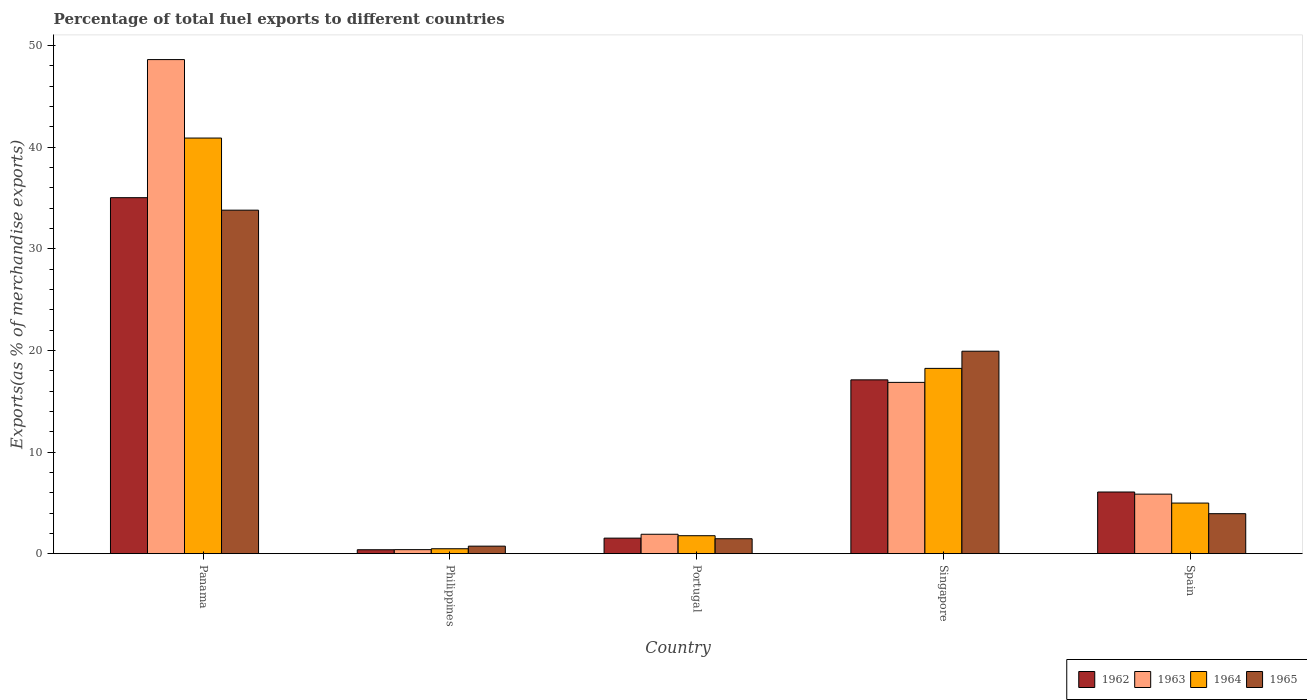How many different coloured bars are there?
Offer a very short reply. 4. How many groups of bars are there?
Provide a short and direct response. 5. What is the percentage of exports to different countries in 1963 in Singapore?
Offer a very short reply. 16.85. Across all countries, what is the maximum percentage of exports to different countries in 1965?
Provide a short and direct response. 33.8. Across all countries, what is the minimum percentage of exports to different countries in 1964?
Offer a terse response. 0.48. In which country was the percentage of exports to different countries in 1963 maximum?
Give a very brief answer. Panama. What is the total percentage of exports to different countries in 1964 in the graph?
Provide a short and direct response. 66.36. What is the difference between the percentage of exports to different countries in 1962 in Singapore and that in Spain?
Keep it short and to the point. 11.04. What is the difference between the percentage of exports to different countries in 1962 in Singapore and the percentage of exports to different countries in 1963 in Spain?
Provide a succinct answer. 11.25. What is the average percentage of exports to different countries in 1963 per country?
Keep it short and to the point. 14.73. What is the difference between the percentage of exports to different countries of/in 1964 and percentage of exports to different countries of/in 1963 in Singapore?
Provide a succinct answer. 1.38. In how many countries, is the percentage of exports to different countries in 1964 greater than 16 %?
Offer a terse response. 2. What is the ratio of the percentage of exports to different countries in 1965 in Panama to that in Singapore?
Ensure brevity in your answer.  1.7. What is the difference between the highest and the second highest percentage of exports to different countries in 1964?
Your response must be concise. 22.67. What is the difference between the highest and the lowest percentage of exports to different countries in 1964?
Make the answer very short. 40.41. In how many countries, is the percentage of exports to different countries in 1965 greater than the average percentage of exports to different countries in 1965 taken over all countries?
Your answer should be compact. 2. Is the sum of the percentage of exports to different countries in 1962 in Philippines and Portugal greater than the maximum percentage of exports to different countries in 1964 across all countries?
Your answer should be very brief. No. What does the 1st bar from the right in Philippines represents?
Ensure brevity in your answer.  1965. How many bars are there?
Give a very brief answer. 20. Are all the bars in the graph horizontal?
Give a very brief answer. No. How many countries are there in the graph?
Keep it short and to the point. 5. What is the difference between two consecutive major ticks on the Y-axis?
Provide a succinct answer. 10. Are the values on the major ticks of Y-axis written in scientific E-notation?
Provide a short and direct response. No. Where does the legend appear in the graph?
Your answer should be compact. Bottom right. How are the legend labels stacked?
Your answer should be compact. Horizontal. What is the title of the graph?
Ensure brevity in your answer.  Percentage of total fuel exports to different countries. What is the label or title of the X-axis?
Give a very brief answer. Country. What is the label or title of the Y-axis?
Ensure brevity in your answer.  Exports(as % of merchandise exports). What is the Exports(as % of merchandise exports) of 1962 in Panama?
Keep it short and to the point. 35.03. What is the Exports(as % of merchandise exports) of 1963 in Panama?
Ensure brevity in your answer.  48.62. What is the Exports(as % of merchandise exports) of 1964 in Panama?
Give a very brief answer. 40.9. What is the Exports(as % of merchandise exports) in 1965 in Panama?
Your answer should be very brief. 33.8. What is the Exports(as % of merchandise exports) of 1962 in Philippines?
Offer a terse response. 0.38. What is the Exports(as % of merchandise exports) in 1963 in Philippines?
Keep it short and to the point. 0.4. What is the Exports(as % of merchandise exports) of 1964 in Philippines?
Your answer should be compact. 0.48. What is the Exports(as % of merchandise exports) of 1965 in Philippines?
Provide a short and direct response. 0.74. What is the Exports(as % of merchandise exports) of 1962 in Portugal?
Your answer should be compact. 1.53. What is the Exports(as % of merchandise exports) in 1963 in Portugal?
Your answer should be very brief. 1.91. What is the Exports(as % of merchandise exports) in 1964 in Portugal?
Give a very brief answer. 1.77. What is the Exports(as % of merchandise exports) in 1965 in Portugal?
Offer a very short reply. 1.47. What is the Exports(as % of merchandise exports) of 1962 in Singapore?
Give a very brief answer. 17.1. What is the Exports(as % of merchandise exports) in 1963 in Singapore?
Make the answer very short. 16.85. What is the Exports(as % of merchandise exports) in 1964 in Singapore?
Give a very brief answer. 18.23. What is the Exports(as % of merchandise exports) of 1965 in Singapore?
Your answer should be compact. 19.92. What is the Exports(as % of merchandise exports) of 1962 in Spain?
Make the answer very short. 6.07. What is the Exports(as % of merchandise exports) in 1963 in Spain?
Provide a short and direct response. 5.86. What is the Exports(as % of merchandise exports) in 1964 in Spain?
Give a very brief answer. 4.98. What is the Exports(as % of merchandise exports) in 1965 in Spain?
Offer a very short reply. 3.93. Across all countries, what is the maximum Exports(as % of merchandise exports) of 1962?
Your answer should be very brief. 35.03. Across all countries, what is the maximum Exports(as % of merchandise exports) in 1963?
Give a very brief answer. 48.62. Across all countries, what is the maximum Exports(as % of merchandise exports) of 1964?
Your answer should be compact. 40.9. Across all countries, what is the maximum Exports(as % of merchandise exports) of 1965?
Offer a terse response. 33.8. Across all countries, what is the minimum Exports(as % of merchandise exports) of 1962?
Your response must be concise. 0.38. Across all countries, what is the minimum Exports(as % of merchandise exports) of 1963?
Your answer should be compact. 0.4. Across all countries, what is the minimum Exports(as % of merchandise exports) in 1964?
Ensure brevity in your answer.  0.48. Across all countries, what is the minimum Exports(as % of merchandise exports) of 1965?
Offer a very short reply. 0.74. What is the total Exports(as % of merchandise exports) of 1962 in the graph?
Ensure brevity in your answer.  60.11. What is the total Exports(as % of merchandise exports) of 1963 in the graph?
Keep it short and to the point. 73.64. What is the total Exports(as % of merchandise exports) in 1964 in the graph?
Give a very brief answer. 66.36. What is the total Exports(as % of merchandise exports) in 1965 in the graph?
Ensure brevity in your answer.  59.87. What is the difference between the Exports(as % of merchandise exports) of 1962 in Panama and that in Philippines?
Provide a succinct answer. 34.65. What is the difference between the Exports(as % of merchandise exports) of 1963 in Panama and that in Philippines?
Keep it short and to the point. 48.22. What is the difference between the Exports(as % of merchandise exports) of 1964 in Panama and that in Philippines?
Ensure brevity in your answer.  40.41. What is the difference between the Exports(as % of merchandise exports) of 1965 in Panama and that in Philippines?
Ensure brevity in your answer.  33.06. What is the difference between the Exports(as % of merchandise exports) in 1962 in Panama and that in Portugal?
Provide a succinct answer. 33.5. What is the difference between the Exports(as % of merchandise exports) in 1963 in Panama and that in Portugal?
Provide a short and direct response. 46.71. What is the difference between the Exports(as % of merchandise exports) in 1964 in Panama and that in Portugal?
Ensure brevity in your answer.  39.13. What is the difference between the Exports(as % of merchandise exports) in 1965 in Panama and that in Portugal?
Offer a terse response. 32.33. What is the difference between the Exports(as % of merchandise exports) of 1962 in Panama and that in Singapore?
Your answer should be very brief. 17.93. What is the difference between the Exports(as % of merchandise exports) of 1963 in Panama and that in Singapore?
Offer a very short reply. 31.77. What is the difference between the Exports(as % of merchandise exports) in 1964 in Panama and that in Singapore?
Provide a short and direct response. 22.67. What is the difference between the Exports(as % of merchandise exports) of 1965 in Panama and that in Singapore?
Your answer should be compact. 13.88. What is the difference between the Exports(as % of merchandise exports) of 1962 in Panama and that in Spain?
Provide a succinct answer. 28.96. What is the difference between the Exports(as % of merchandise exports) of 1963 in Panama and that in Spain?
Offer a very short reply. 42.76. What is the difference between the Exports(as % of merchandise exports) of 1964 in Panama and that in Spain?
Offer a very short reply. 35.92. What is the difference between the Exports(as % of merchandise exports) of 1965 in Panama and that in Spain?
Keep it short and to the point. 29.87. What is the difference between the Exports(as % of merchandise exports) in 1962 in Philippines and that in Portugal?
Offer a terse response. -1.14. What is the difference between the Exports(as % of merchandise exports) in 1963 in Philippines and that in Portugal?
Provide a short and direct response. -1.51. What is the difference between the Exports(as % of merchandise exports) of 1964 in Philippines and that in Portugal?
Ensure brevity in your answer.  -1.28. What is the difference between the Exports(as % of merchandise exports) in 1965 in Philippines and that in Portugal?
Offer a terse response. -0.73. What is the difference between the Exports(as % of merchandise exports) of 1962 in Philippines and that in Singapore?
Offer a terse response. -16.72. What is the difference between the Exports(as % of merchandise exports) of 1963 in Philippines and that in Singapore?
Your response must be concise. -16.46. What is the difference between the Exports(as % of merchandise exports) of 1964 in Philippines and that in Singapore?
Your response must be concise. -17.75. What is the difference between the Exports(as % of merchandise exports) in 1965 in Philippines and that in Singapore?
Offer a terse response. -19.18. What is the difference between the Exports(as % of merchandise exports) in 1962 in Philippines and that in Spain?
Make the answer very short. -5.68. What is the difference between the Exports(as % of merchandise exports) of 1963 in Philippines and that in Spain?
Offer a terse response. -5.46. What is the difference between the Exports(as % of merchandise exports) of 1964 in Philippines and that in Spain?
Offer a terse response. -4.49. What is the difference between the Exports(as % of merchandise exports) in 1965 in Philippines and that in Spain?
Keep it short and to the point. -3.19. What is the difference between the Exports(as % of merchandise exports) of 1962 in Portugal and that in Singapore?
Your answer should be very brief. -15.58. What is the difference between the Exports(as % of merchandise exports) of 1963 in Portugal and that in Singapore?
Your answer should be compact. -14.95. What is the difference between the Exports(as % of merchandise exports) in 1964 in Portugal and that in Singapore?
Your answer should be compact. -16.47. What is the difference between the Exports(as % of merchandise exports) in 1965 in Portugal and that in Singapore?
Your response must be concise. -18.45. What is the difference between the Exports(as % of merchandise exports) of 1962 in Portugal and that in Spain?
Provide a short and direct response. -4.54. What is the difference between the Exports(as % of merchandise exports) of 1963 in Portugal and that in Spain?
Give a very brief answer. -3.95. What is the difference between the Exports(as % of merchandise exports) in 1964 in Portugal and that in Spain?
Your answer should be compact. -3.21. What is the difference between the Exports(as % of merchandise exports) of 1965 in Portugal and that in Spain?
Your response must be concise. -2.46. What is the difference between the Exports(as % of merchandise exports) of 1962 in Singapore and that in Spain?
Your answer should be compact. 11.04. What is the difference between the Exports(as % of merchandise exports) in 1963 in Singapore and that in Spain?
Provide a succinct answer. 11. What is the difference between the Exports(as % of merchandise exports) of 1964 in Singapore and that in Spain?
Keep it short and to the point. 13.25. What is the difference between the Exports(as % of merchandise exports) in 1965 in Singapore and that in Spain?
Offer a very short reply. 15.99. What is the difference between the Exports(as % of merchandise exports) of 1962 in Panama and the Exports(as % of merchandise exports) of 1963 in Philippines?
Give a very brief answer. 34.63. What is the difference between the Exports(as % of merchandise exports) in 1962 in Panama and the Exports(as % of merchandise exports) in 1964 in Philippines?
Your response must be concise. 34.55. What is the difference between the Exports(as % of merchandise exports) in 1962 in Panama and the Exports(as % of merchandise exports) in 1965 in Philippines?
Ensure brevity in your answer.  34.29. What is the difference between the Exports(as % of merchandise exports) of 1963 in Panama and the Exports(as % of merchandise exports) of 1964 in Philippines?
Give a very brief answer. 48.14. What is the difference between the Exports(as % of merchandise exports) in 1963 in Panama and the Exports(as % of merchandise exports) in 1965 in Philippines?
Keep it short and to the point. 47.88. What is the difference between the Exports(as % of merchandise exports) in 1964 in Panama and the Exports(as % of merchandise exports) in 1965 in Philippines?
Provide a short and direct response. 40.16. What is the difference between the Exports(as % of merchandise exports) of 1962 in Panama and the Exports(as % of merchandise exports) of 1963 in Portugal?
Keep it short and to the point. 33.12. What is the difference between the Exports(as % of merchandise exports) of 1962 in Panama and the Exports(as % of merchandise exports) of 1964 in Portugal?
Your answer should be very brief. 33.26. What is the difference between the Exports(as % of merchandise exports) in 1962 in Panama and the Exports(as % of merchandise exports) in 1965 in Portugal?
Provide a short and direct response. 33.56. What is the difference between the Exports(as % of merchandise exports) in 1963 in Panama and the Exports(as % of merchandise exports) in 1964 in Portugal?
Provide a succinct answer. 46.85. What is the difference between the Exports(as % of merchandise exports) in 1963 in Panama and the Exports(as % of merchandise exports) in 1965 in Portugal?
Make the answer very short. 47.15. What is the difference between the Exports(as % of merchandise exports) in 1964 in Panama and the Exports(as % of merchandise exports) in 1965 in Portugal?
Ensure brevity in your answer.  39.43. What is the difference between the Exports(as % of merchandise exports) in 1962 in Panama and the Exports(as % of merchandise exports) in 1963 in Singapore?
Provide a short and direct response. 18.18. What is the difference between the Exports(as % of merchandise exports) of 1962 in Panama and the Exports(as % of merchandise exports) of 1964 in Singapore?
Offer a very short reply. 16.8. What is the difference between the Exports(as % of merchandise exports) in 1962 in Panama and the Exports(as % of merchandise exports) in 1965 in Singapore?
Offer a terse response. 15.11. What is the difference between the Exports(as % of merchandise exports) in 1963 in Panama and the Exports(as % of merchandise exports) in 1964 in Singapore?
Your response must be concise. 30.39. What is the difference between the Exports(as % of merchandise exports) in 1963 in Panama and the Exports(as % of merchandise exports) in 1965 in Singapore?
Offer a terse response. 28.7. What is the difference between the Exports(as % of merchandise exports) of 1964 in Panama and the Exports(as % of merchandise exports) of 1965 in Singapore?
Provide a short and direct response. 20.98. What is the difference between the Exports(as % of merchandise exports) of 1962 in Panama and the Exports(as % of merchandise exports) of 1963 in Spain?
Offer a very short reply. 29.17. What is the difference between the Exports(as % of merchandise exports) in 1962 in Panama and the Exports(as % of merchandise exports) in 1964 in Spain?
Make the answer very short. 30.05. What is the difference between the Exports(as % of merchandise exports) in 1962 in Panama and the Exports(as % of merchandise exports) in 1965 in Spain?
Provide a short and direct response. 31.1. What is the difference between the Exports(as % of merchandise exports) of 1963 in Panama and the Exports(as % of merchandise exports) of 1964 in Spain?
Your answer should be compact. 43.64. What is the difference between the Exports(as % of merchandise exports) in 1963 in Panama and the Exports(as % of merchandise exports) in 1965 in Spain?
Your answer should be very brief. 44.69. What is the difference between the Exports(as % of merchandise exports) of 1964 in Panama and the Exports(as % of merchandise exports) of 1965 in Spain?
Offer a terse response. 36.96. What is the difference between the Exports(as % of merchandise exports) in 1962 in Philippines and the Exports(as % of merchandise exports) in 1963 in Portugal?
Give a very brief answer. -1.52. What is the difference between the Exports(as % of merchandise exports) in 1962 in Philippines and the Exports(as % of merchandise exports) in 1964 in Portugal?
Your answer should be compact. -1.38. What is the difference between the Exports(as % of merchandise exports) of 1962 in Philippines and the Exports(as % of merchandise exports) of 1965 in Portugal?
Make the answer very short. -1.08. What is the difference between the Exports(as % of merchandise exports) of 1963 in Philippines and the Exports(as % of merchandise exports) of 1964 in Portugal?
Make the answer very short. -1.37. What is the difference between the Exports(as % of merchandise exports) in 1963 in Philippines and the Exports(as % of merchandise exports) in 1965 in Portugal?
Your answer should be very brief. -1.07. What is the difference between the Exports(as % of merchandise exports) of 1964 in Philippines and the Exports(as % of merchandise exports) of 1965 in Portugal?
Provide a short and direct response. -0.99. What is the difference between the Exports(as % of merchandise exports) of 1962 in Philippines and the Exports(as % of merchandise exports) of 1963 in Singapore?
Offer a terse response. -16.47. What is the difference between the Exports(as % of merchandise exports) in 1962 in Philippines and the Exports(as % of merchandise exports) in 1964 in Singapore?
Give a very brief answer. -17.85. What is the difference between the Exports(as % of merchandise exports) of 1962 in Philippines and the Exports(as % of merchandise exports) of 1965 in Singapore?
Make the answer very short. -19.54. What is the difference between the Exports(as % of merchandise exports) of 1963 in Philippines and the Exports(as % of merchandise exports) of 1964 in Singapore?
Offer a very short reply. -17.84. What is the difference between the Exports(as % of merchandise exports) of 1963 in Philippines and the Exports(as % of merchandise exports) of 1965 in Singapore?
Offer a very short reply. -19.53. What is the difference between the Exports(as % of merchandise exports) in 1964 in Philippines and the Exports(as % of merchandise exports) in 1965 in Singapore?
Give a very brief answer. -19.44. What is the difference between the Exports(as % of merchandise exports) of 1962 in Philippines and the Exports(as % of merchandise exports) of 1963 in Spain?
Your answer should be very brief. -5.47. What is the difference between the Exports(as % of merchandise exports) of 1962 in Philippines and the Exports(as % of merchandise exports) of 1964 in Spain?
Keep it short and to the point. -4.59. What is the difference between the Exports(as % of merchandise exports) in 1962 in Philippines and the Exports(as % of merchandise exports) in 1965 in Spain?
Make the answer very short. -3.55. What is the difference between the Exports(as % of merchandise exports) of 1963 in Philippines and the Exports(as % of merchandise exports) of 1964 in Spain?
Make the answer very short. -4.58. What is the difference between the Exports(as % of merchandise exports) in 1963 in Philippines and the Exports(as % of merchandise exports) in 1965 in Spain?
Keep it short and to the point. -3.54. What is the difference between the Exports(as % of merchandise exports) in 1964 in Philippines and the Exports(as % of merchandise exports) in 1965 in Spain?
Provide a succinct answer. -3.45. What is the difference between the Exports(as % of merchandise exports) in 1962 in Portugal and the Exports(as % of merchandise exports) in 1963 in Singapore?
Make the answer very short. -15.33. What is the difference between the Exports(as % of merchandise exports) of 1962 in Portugal and the Exports(as % of merchandise exports) of 1964 in Singapore?
Offer a terse response. -16.7. What is the difference between the Exports(as % of merchandise exports) of 1962 in Portugal and the Exports(as % of merchandise exports) of 1965 in Singapore?
Your answer should be compact. -18.39. What is the difference between the Exports(as % of merchandise exports) of 1963 in Portugal and the Exports(as % of merchandise exports) of 1964 in Singapore?
Offer a terse response. -16.32. What is the difference between the Exports(as % of merchandise exports) in 1963 in Portugal and the Exports(as % of merchandise exports) in 1965 in Singapore?
Ensure brevity in your answer.  -18.01. What is the difference between the Exports(as % of merchandise exports) in 1964 in Portugal and the Exports(as % of merchandise exports) in 1965 in Singapore?
Offer a very short reply. -18.16. What is the difference between the Exports(as % of merchandise exports) in 1962 in Portugal and the Exports(as % of merchandise exports) in 1963 in Spain?
Keep it short and to the point. -4.33. What is the difference between the Exports(as % of merchandise exports) in 1962 in Portugal and the Exports(as % of merchandise exports) in 1964 in Spain?
Your answer should be very brief. -3.45. What is the difference between the Exports(as % of merchandise exports) of 1962 in Portugal and the Exports(as % of merchandise exports) of 1965 in Spain?
Keep it short and to the point. -2.41. What is the difference between the Exports(as % of merchandise exports) in 1963 in Portugal and the Exports(as % of merchandise exports) in 1964 in Spain?
Your answer should be compact. -3.07. What is the difference between the Exports(as % of merchandise exports) of 1963 in Portugal and the Exports(as % of merchandise exports) of 1965 in Spain?
Offer a very short reply. -2.03. What is the difference between the Exports(as % of merchandise exports) in 1964 in Portugal and the Exports(as % of merchandise exports) in 1965 in Spain?
Give a very brief answer. -2.17. What is the difference between the Exports(as % of merchandise exports) of 1962 in Singapore and the Exports(as % of merchandise exports) of 1963 in Spain?
Provide a succinct answer. 11.25. What is the difference between the Exports(as % of merchandise exports) of 1962 in Singapore and the Exports(as % of merchandise exports) of 1964 in Spain?
Your answer should be very brief. 12.13. What is the difference between the Exports(as % of merchandise exports) in 1962 in Singapore and the Exports(as % of merchandise exports) in 1965 in Spain?
Your response must be concise. 13.17. What is the difference between the Exports(as % of merchandise exports) of 1963 in Singapore and the Exports(as % of merchandise exports) of 1964 in Spain?
Give a very brief answer. 11.88. What is the difference between the Exports(as % of merchandise exports) of 1963 in Singapore and the Exports(as % of merchandise exports) of 1965 in Spain?
Your response must be concise. 12.92. What is the difference between the Exports(as % of merchandise exports) in 1964 in Singapore and the Exports(as % of merchandise exports) in 1965 in Spain?
Make the answer very short. 14.3. What is the average Exports(as % of merchandise exports) of 1962 per country?
Your answer should be very brief. 12.02. What is the average Exports(as % of merchandise exports) of 1963 per country?
Your answer should be compact. 14.73. What is the average Exports(as % of merchandise exports) in 1964 per country?
Give a very brief answer. 13.27. What is the average Exports(as % of merchandise exports) in 1965 per country?
Your answer should be very brief. 11.97. What is the difference between the Exports(as % of merchandise exports) in 1962 and Exports(as % of merchandise exports) in 1963 in Panama?
Offer a terse response. -13.59. What is the difference between the Exports(as % of merchandise exports) of 1962 and Exports(as % of merchandise exports) of 1964 in Panama?
Make the answer very short. -5.87. What is the difference between the Exports(as % of merchandise exports) in 1962 and Exports(as % of merchandise exports) in 1965 in Panama?
Your response must be concise. 1.23. What is the difference between the Exports(as % of merchandise exports) in 1963 and Exports(as % of merchandise exports) in 1964 in Panama?
Keep it short and to the point. 7.72. What is the difference between the Exports(as % of merchandise exports) of 1963 and Exports(as % of merchandise exports) of 1965 in Panama?
Offer a very short reply. 14.82. What is the difference between the Exports(as % of merchandise exports) in 1964 and Exports(as % of merchandise exports) in 1965 in Panama?
Your answer should be very brief. 7.1. What is the difference between the Exports(as % of merchandise exports) in 1962 and Exports(as % of merchandise exports) in 1963 in Philippines?
Offer a terse response. -0.01. What is the difference between the Exports(as % of merchandise exports) of 1962 and Exports(as % of merchandise exports) of 1964 in Philippines?
Your answer should be very brief. -0.1. What is the difference between the Exports(as % of merchandise exports) of 1962 and Exports(as % of merchandise exports) of 1965 in Philippines?
Ensure brevity in your answer.  -0.35. What is the difference between the Exports(as % of merchandise exports) in 1963 and Exports(as % of merchandise exports) in 1964 in Philippines?
Provide a short and direct response. -0.09. What is the difference between the Exports(as % of merchandise exports) in 1963 and Exports(as % of merchandise exports) in 1965 in Philippines?
Your response must be concise. -0.34. What is the difference between the Exports(as % of merchandise exports) of 1964 and Exports(as % of merchandise exports) of 1965 in Philippines?
Your answer should be compact. -0.26. What is the difference between the Exports(as % of merchandise exports) in 1962 and Exports(as % of merchandise exports) in 1963 in Portugal?
Keep it short and to the point. -0.38. What is the difference between the Exports(as % of merchandise exports) of 1962 and Exports(as % of merchandise exports) of 1964 in Portugal?
Your response must be concise. -0.24. What is the difference between the Exports(as % of merchandise exports) of 1962 and Exports(as % of merchandise exports) of 1965 in Portugal?
Offer a terse response. 0.06. What is the difference between the Exports(as % of merchandise exports) in 1963 and Exports(as % of merchandise exports) in 1964 in Portugal?
Your answer should be compact. 0.14. What is the difference between the Exports(as % of merchandise exports) of 1963 and Exports(as % of merchandise exports) of 1965 in Portugal?
Make the answer very short. 0.44. What is the difference between the Exports(as % of merchandise exports) of 1964 and Exports(as % of merchandise exports) of 1965 in Portugal?
Make the answer very short. 0.3. What is the difference between the Exports(as % of merchandise exports) of 1962 and Exports(as % of merchandise exports) of 1963 in Singapore?
Keep it short and to the point. 0.25. What is the difference between the Exports(as % of merchandise exports) of 1962 and Exports(as % of merchandise exports) of 1964 in Singapore?
Provide a succinct answer. -1.13. What is the difference between the Exports(as % of merchandise exports) of 1962 and Exports(as % of merchandise exports) of 1965 in Singapore?
Give a very brief answer. -2.82. What is the difference between the Exports(as % of merchandise exports) of 1963 and Exports(as % of merchandise exports) of 1964 in Singapore?
Your answer should be very brief. -1.38. What is the difference between the Exports(as % of merchandise exports) of 1963 and Exports(as % of merchandise exports) of 1965 in Singapore?
Ensure brevity in your answer.  -3.07. What is the difference between the Exports(as % of merchandise exports) of 1964 and Exports(as % of merchandise exports) of 1965 in Singapore?
Ensure brevity in your answer.  -1.69. What is the difference between the Exports(as % of merchandise exports) of 1962 and Exports(as % of merchandise exports) of 1963 in Spain?
Give a very brief answer. 0.21. What is the difference between the Exports(as % of merchandise exports) in 1962 and Exports(as % of merchandise exports) in 1964 in Spain?
Provide a short and direct response. 1.09. What is the difference between the Exports(as % of merchandise exports) of 1962 and Exports(as % of merchandise exports) of 1965 in Spain?
Ensure brevity in your answer.  2.13. What is the difference between the Exports(as % of merchandise exports) in 1963 and Exports(as % of merchandise exports) in 1964 in Spain?
Offer a very short reply. 0.88. What is the difference between the Exports(as % of merchandise exports) in 1963 and Exports(as % of merchandise exports) in 1965 in Spain?
Give a very brief answer. 1.92. What is the difference between the Exports(as % of merchandise exports) of 1964 and Exports(as % of merchandise exports) of 1965 in Spain?
Make the answer very short. 1.04. What is the ratio of the Exports(as % of merchandise exports) of 1962 in Panama to that in Philippines?
Provide a short and direct response. 91.01. What is the ratio of the Exports(as % of merchandise exports) of 1963 in Panama to that in Philippines?
Give a very brief answer. 122.82. What is the ratio of the Exports(as % of merchandise exports) in 1964 in Panama to that in Philippines?
Offer a terse response. 84.6. What is the ratio of the Exports(as % of merchandise exports) of 1965 in Panama to that in Philippines?
Your response must be concise. 45.69. What is the ratio of the Exports(as % of merchandise exports) of 1962 in Panama to that in Portugal?
Ensure brevity in your answer.  22.92. What is the ratio of the Exports(as % of merchandise exports) of 1963 in Panama to that in Portugal?
Your answer should be compact. 25.47. What is the ratio of the Exports(as % of merchandise exports) in 1964 in Panama to that in Portugal?
Ensure brevity in your answer.  23.15. What is the ratio of the Exports(as % of merchandise exports) of 1965 in Panama to that in Portugal?
Your response must be concise. 23. What is the ratio of the Exports(as % of merchandise exports) of 1962 in Panama to that in Singapore?
Make the answer very short. 2.05. What is the ratio of the Exports(as % of merchandise exports) of 1963 in Panama to that in Singapore?
Provide a succinct answer. 2.88. What is the ratio of the Exports(as % of merchandise exports) of 1964 in Panama to that in Singapore?
Offer a terse response. 2.24. What is the ratio of the Exports(as % of merchandise exports) of 1965 in Panama to that in Singapore?
Your answer should be compact. 1.7. What is the ratio of the Exports(as % of merchandise exports) of 1962 in Panama to that in Spain?
Make the answer very short. 5.77. What is the ratio of the Exports(as % of merchandise exports) in 1963 in Panama to that in Spain?
Provide a short and direct response. 8.3. What is the ratio of the Exports(as % of merchandise exports) in 1964 in Panama to that in Spain?
Offer a very short reply. 8.22. What is the ratio of the Exports(as % of merchandise exports) in 1965 in Panama to that in Spain?
Offer a very short reply. 8.59. What is the ratio of the Exports(as % of merchandise exports) of 1962 in Philippines to that in Portugal?
Your answer should be compact. 0.25. What is the ratio of the Exports(as % of merchandise exports) of 1963 in Philippines to that in Portugal?
Offer a terse response. 0.21. What is the ratio of the Exports(as % of merchandise exports) of 1964 in Philippines to that in Portugal?
Your answer should be very brief. 0.27. What is the ratio of the Exports(as % of merchandise exports) in 1965 in Philippines to that in Portugal?
Provide a succinct answer. 0.5. What is the ratio of the Exports(as % of merchandise exports) of 1962 in Philippines to that in Singapore?
Give a very brief answer. 0.02. What is the ratio of the Exports(as % of merchandise exports) in 1963 in Philippines to that in Singapore?
Make the answer very short. 0.02. What is the ratio of the Exports(as % of merchandise exports) in 1964 in Philippines to that in Singapore?
Your response must be concise. 0.03. What is the ratio of the Exports(as % of merchandise exports) in 1965 in Philippines to that in Singapore?
Your response must be concise. 0.04. What is the ratio of the Exports(as % of merchandise exports) in 1962 in Philippines to that in Spain?
Give a very brief answer. 0.06. What is the ratio of the Exports(as % of merchandise exports) in 1963 in Philippines to that in Spain?
Provide a succinct answer. 0.07. What is the ratio of the Exports(as % of merchandise exports) in 1964 in Philippines to that in Spain?
Your response must be concise. 0.1. What is the ratio of the Exports(as % of merchandise exports) in 1965 in Philippines to that in Spain?
Your answer should be very brief. 0.19. What is the ratio of the Exports(as % of merchandise exports) of 1962 in Portugal to that in Singapore?
Provide a short and direct response. 0.09. What is the ratio of the Exports(as % of merchandise exports) of 1963 in Portugal to that in Singapore?
Offer a terse response. 0.11. What is the ratio of the Exports(as % of merchandise exports) of 1964 in Portugal to that in Singapore?
Make the answer very short. 0.1. What is the ratio of the Exports(as % of merchandise exports) in 1965 in Portugal to that in Singapore?
Provide a short and direct response. 0.07. What is the ratio of the Exports(as % of merchandise exports) in 1962 in Portugal to that in Spain?
Provide a short and direct response. 0.25. What is the ratio of the Exports(as % of merchandise exports) of 1963 in Portugal to that in Spain?
Offer a terse response. 0.33. What is the ratio of the Exports(as % of merchandise exports) of 1964 in Portugal to that in Spain?
Offer a very short reply. 0.35. What is the ratio of the Exports(as % of merchandise exports) of 1965 in Portugal to that in Spain?
Offer a very short reply. 0.37. What is the ratio of the Exports(as % of merchandise exports) in 1962 in Singapore to that in Spain?
Offer a very short reply. 2.82. What is the ratio of the Exports(as % of merchandise exports) in 1963 in Singapore to that in Spain?
Your answer should be very brief. 2.88. What is the ratio of the Exports(as % of merchandise exports) of 1964 in Singapore to that in Spain?
Make the answer very short. 3.66. What is the ratio of the Exports(as % of merchandise exports) in 1965 in Singapore to that in Spain?
Provide a short and direct response. 5.06. What is the difference between the highest and the second highest Exports(as % of merchandise exports) of 1962?
Your answer should be compact. 17.93. What is the difference between the highest and the second highest Exports(as % of merchandise exports) of 1963?
Keep it short and to the point. 31.77. What is the difference between the highest and the second highest Exports(as % of merchandise exports) in 1964?
Provide a short and direct response. 22.67. What is the difference between the highest and the second highest Exports(as % of merchandise exports) in 1965?
Ensure brevity in your answer.  13.88. What is the difference between the highest and the lowest Exports(as % of merchandise exports) in 1962?
Provide a succinct answer. 34.65. What is the difference between the highest and the lowest Exports(as % of merchandise exports) of 1963?
Your answer should be compact. 48.22. What is the difference between the highest and the lowest Exports(as % of merchandise exports) in 1964?
Keep it short and to the point. 40.41. What is the difference between the highest and the lowest Exports(as % of merchandise exports) in 1965?
Make the answer very short. 33.06. 